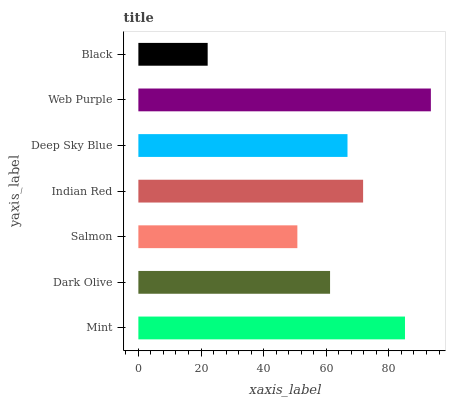Is Black the minimum?
Answer yes or no. Yes. Is Web Purple the maximum?
Answer yes or no. Yes. Is Dark Olive the minimum?
Answer yes or no. No. Is Dark Olive the maximum?
Answer yes or no. No. Is Mint greater than Dark Olive?
Answer yes or no. Yes. Is Dark Olive less than Mint?
Answer yes or no. Yes. Is Dark Olive greater than Mint?
Answer yes or no. No. Is Mint less than Dark Olive?
Answer yes or no. No. Is Deep Sky Blue the high median?
Answer yes or no. Yes. Is Deep Sky Blue the low median?
Answer yes or no. Yes. Is Salmon the high median?
Answer yes or no. No. Is Salmon the low median?
Answer yes or no. No. 